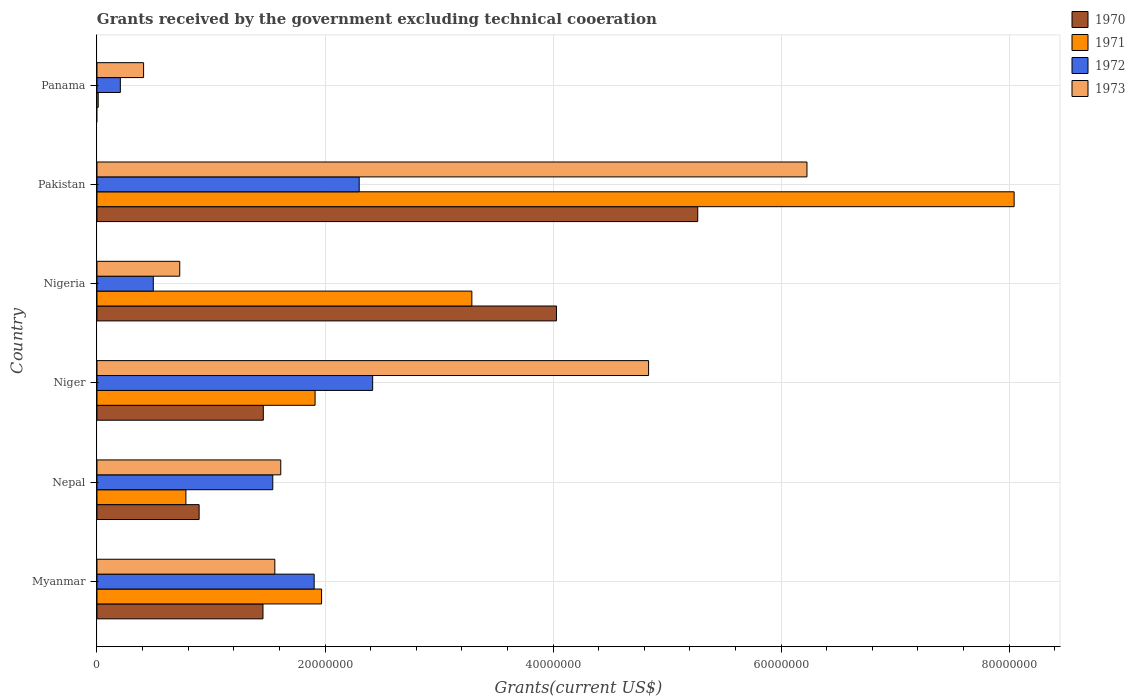How many different coloured bars are there?
Give a very brief answer. 4. Are the number of bars on each tick of the Y-axis equal?
Ensure brevity in your answer.  No. How many bars are there on the 2nd tick from the bottom?
Your answer should be very brief. 4. What is the label of the 2nd group of bars from the top?
Provide a short and direct response. Pakistan. In how many cases, is the number of bars for a given country not equal to the number of legend labels?
Your answer should be compact. 1. What is the total grants received by the government in 1970 in Pakistan?
Keep it short and to the point. 5.27e+07. Across all countries, what is the maximum total grants received by the government in 1973?
Offer a terse response. 6.23e+07. In which country was the total grants received by the government in 1973 maximum?
Keep it short and to the point. Pakistan. What is the total total grants received by the government in 1970 in the graph?
Provide a short and direct response. 1.31e+08. What is the difference between the total grants received by the government in 1971 in Niger and that in Nigeria?
Keep it short and to the point. -1.38e+07. What is the difference between the total grants received by the government in 1970 in Myanmar and the total grants received by the government in 1973 in Pakistan?
Ensure brevity in your answer.  -4.77e+07. What is the average total grants received by the government in 1971 per country?
Your answer should be very brief. 2.67e+07. What is the difference between the total grants received by the government in 1972 and total grants received by the government in 1971 in Nigeria?
Offer a terse response. -2.79e+07. In how many countries, is the total grants received by the government in 1971 greater than 64000000 US$?
Provide a succinct answer. 1. What is the ratio of the total grants received by the government in 1970 in Nepal to that in Niger?
Provide a short and direct response. 0.61. What is the difference between the highest and the second highest total grants received by the government in 1971?
Offer a very short reply. 4.76e+07. What is the difference between the highest and the lowest total grants received by the government in 1972?
Offer a terse response. 2.21e+07. In how many countries, is the total grants received by the government in 1972 greater than the average total grants received by the government in 1972 taken over all countries?
Your answer should be very brief. 4. How many bars are there?
Your answer should be very brief. 23. Are all the bars in the graph horizontal?
Offer a very short reply. Yes. What is the difference between two consecutive major ticks on the X-axis?
Provide a short and direct response. 2.00e+07. Does the graph contain any zero values?
Keep it short and to the point. Yes. Where does the legend appear in the graph?
Provide a short and direct response. Top right. How many legend labels are there?
Your answer should be compact. 4. How are the legend labels stacked?
Make the answer very short. Vertical. What is the title of the graph?
Your answer should be compact. Grants received by the government excluding technical cooeration. What is the label or title of the X-axis?
Ensure brevity in your answer.  Grants(current US$). What is the Grants(current US$) in 1970 in Myanmar?
Provide a short and direct response. 1.46e+07. What is the Grants(current US$) of 1971 in Myanmar?
Keep it short and to the point. 1.97e+07. What is the Grants(current US$) in 1972 in Myanmar?
Offer a very short reply. 1.90e+07. What is the Grants(current US$) in 1973 in Myanmar?
Your answer should be compact. 1.56e+07. What is the Grants(current US$) in 1970 in Nepal?
Provide a short and direct response. 8.96e+06. What is the Grants(current US$) in 1971 in Nepal?
Give a very brief answer. 7.80e+06. What is the Grants(current US$) in 1972 in Nepal?
Give a very brief answer. 1.54e+07. What is the Grants(current US$) of 1973 in Nepal?
Provide a short and direct response. 1.61e+07. What is the Grants(current US$) of 1970 in Niger?
Your response must be concise. 1.46e+07. What is the Grants(current US$) in 1971 in Niger?
Your answer should be very brief. 1.91e+07. What is the Grants(current US$) of 1972 in Niger?
Provide a succinct answer. 2.42e+07. What is the Grants(current US$) in 1973 in Niger?
Your response must be concise. 4.84e+07. What is the Grants(current US$) in 1970 in Nigeria?
Provide a succinct answer. 4.03e+07. What is the Grants(current US$) of 1971 in Nigeria?
Provide a succinct answer. 3.29e+07. What is the Grants(current US$) of 1972 in Nigeria?
Provide a short and direct response. 4.94e+06. What is the Grants(current US$) in 1973 in Nigeria?
Offer a terse response. 7.26e+06. What is the Grants(current US$) in 1970 in Pakistan?
Ensure brevity in your answer.  5.27e+07. What is the Grants(current US$) of 1971 in Pakistan?
Your answer should be compact. 8.04e+07. What is the Grants(current US$) in 1972 in Pakistan?
Keep it short and to the point. 2.30e+07. What is the Grants(current US$) in 1973 in Pakistan?
Provide a short and direct response. 6.23e+07. What is the Grants(current US$) in 1970 in Panama?
Make the answer very short. 0. What is the Grants(current US$) of 1971 in Panama?
Ensure brevity in your answer.  1.10e+05. What is the Grants(current US$) of 1972 in Panama?
Give a very brief answer. 2.05e+06. What is the Grants(current US$) of 1973 in Panama?
Give a very brief answer. 4.09e+06. Across all countries, what is the maximum Grants(current US$) in 1970?
Give a very brief answer. 5.27e+07. Across all countries, what is the maximum Grants(current US$) in 1971?
Give a very brief answer. 8.04e+07. Across all countries, what is the maximum Grants(current US$) in 1972?
Provide a succinct answer. 2.42e+07. Across all countries, what is the maximum Grants(current US$) of 1973?
Give a very brief answer. 6.23e+07. Across all countries, what is the minimum Grants(current US$) in 1970?
Provide a succinct answer. 0. Across all countries, what is the minimum Grants(current US$) in 1971?
Ensure brevity in your answer.  1.10e+05. Across all countries, what is the minimum Grants(current US$) in 1972?
Keep it short and to the point. 2.05e+06. Across all countries, what is the minimum Grants(current US$) of 1973?
Give a very brief answer. 4.09e+06. What is the total Grants(current US$) of 1970 in the graph?
Your answer should be compact. 1.31e+08. What is the total Grants(current US$) in 1971 in the graph?
Make the answer very short. 1.60e+08. What is the total Grants(current US$) of 1972 in the graph?
Your answer should be very brief. 8.86e+07. What is the total Grants(current US$) of 1973 in the graph?
Give a very brief answer. 1.54e+08. What is the difference between the Grants(current US$) in 1970 in Myanmar and that in Nepal?
Keep it short and to the point. 5.60e+06. What is the difference between the Grants(current US$) of 1971 in Myanmar and that in Nepal?
Make the answer very short. 1.19e+07. What is the difference between the Grants(current US$) of 1972 in Myanmar and that in Nepal?
Make the answer very short. 3.63e+06. What is the difference between the Grants(current US$) in 1973 in Myanmar and that in Nepal?
Offer a very short reply. -5.20e+05. What is the difference between the Grants(current US$) of 1971 in Myanmar and that in Niger?
Ensure brevity in your answer.  5.70e+05. What is the difference between the Grants(current US$) of 1972 in Myanmar and that in Niger?
Keep it short and to the point. -5.13e+06. What is the difference between the Grants(current US$) in 1973 in Myanmar and that in Niger?
Provide a succinct answer. -3.28e+07. What is the difference between the Grants(current US$) of 1970 in Myanmar and that in Nigeria?
Ensure brevity in your answer.  -2.57e+07. What is the difference between the Grants(current US$) in 1971 in Myanmar and that in Nigeria?
Ensure brevity in your answer.  -1.32e+07. What is the difference between the Grants(current US$) in 1972 in Myanmar and that in Nigeria?
Keep it short and to the point. 1.41e+07. What is the difference between the Grants(current US$) of 1973 in Myanmar and that in Nigeria?
Ensure brevity in your answer.  8.34e+06. What is the difference between the Grants(current US$) in 1970 in Myanmar and that in Pakistan?
Keep it short and to the point. -3.81e+07. What is the difference between the Grants(current US$) of 1971 in Myanmar and that in Pakistan?
Offer a terse response. -6.07e+07. What is the difference between the Grants(current US$) in 1972 in Myanmar and that in Pakistan?
Make the answer very short. -3.95e+06. What is the difference between the Grants(current US$) in 1973 in Myanmar and that in Pakistan?
Provide a short and direct response. -4.67e+07. What is the difference between the Grants(current US$) in 1971 in Myanmar and that in Panama?
Your response must be concise. 1.96e+07. What is the difference between the Grants(current US$) of 1972 in Myanmar and that in Panama?
Provide a succinct answer. 1.70e+07. What is the difference between the Grants(current US$) in 1973 in Myanmar and that in Panama?
Offer a terse response. 1.15e+07. What is the difference between the Grants(current US$) in 1970 in Nepal and that in Niger?
Make the answer very short. -5.63e+06. What is the difference between the Grants(current US$) in 1971 in Nepal and that in Niger?
Your response must be concise. -1.13e+07. What is the difference between the Grants(current US$) in 1972 in Nepal and that in Niger?
Your response must be concise. -8.76e+06. What is the difference between the Grants(current US$) in 1973 in Nepal and that in Niger?
Your response must be concise. -3.23e+07. What is the difference between the Grants(current US$) of 1970 in Nepal and that in Nigeria?
Your answer should be compact. -3.13e+07. What is the difference between the Grants(current US$) in 1971 in Nepal and that in Nigeria?
Give a very brief answer. -2.51e+07. What is the difference between the Grants(current US$) of 1972 in Nepal and that in Nigeria?
Make the answer very short. 1.05e+07. What is the difference between the Grants(current US$) of 1973 in Nepal and that in Nigeria?
Offer a very short reply. 8.86e+06. What is the difference between the Grants(current US$) of 1970 in Nepal and that in Pakistan?
Give a very brief answer. -4.37e+07. What is the difference between the Grants(current US$) of 1971 in Nepal and that in Pakistan?
Ensure brevity in your answer.  -7.26e+07. What is the difference between the Grants(current US$) of 1972 in Nepal and that in Pakistan?
Ensure brevity in your answer.  -7.58e+06. What is the difference between the Grants(current US$) in 1973 in Nepal and that in Pakistan?
Your response must be concise. -4.62e+07. What is the difference between the Grants(current US$) in 1971 in Nepal and that in Panama?
Your response must be concise. 7.69e+06. What is the difference between the Grants(current US$) of 1972 in Nepal and that in Panama?
Make the answer very short. 1.34e+07. What is the difference between the Grants(current US$) in 1973 in Nepal and that in Panama?
Offer a terse response. 1.20e+07. What is the difference between the Grants(current US$) in 1970 in Niger and that in Nigeria?
Make the answer very short. -2.57e+07. What is the difference between the Grants(current US$) of 1971 in Niger and that in Nigeria?
Give a very brief answer. -1.38e+07. What is the difference between the Grants(current US$) in 1972 in Niger and that in Nigeria?
Provide a short and direct response. 1.92e+07. What is the difference between the Grants(current US$) of 1973 in Niger and that in Nigeria?
Provide a short and direct response. 4.11e+07. What is the difference between the Grants(current US$) in 1970 in Niger and that in Pakistan?
Your answer should be compact. -3.81e+07. What is the difference between the Grants(current US$) in 1971 in Niger and that in Pakistan?
Your answer should be very brief. -6.13e+07. What is the difference between the Grants(current US$) in 1972 in Niger and that in Pakistan?
Keep it short and to the point. 1.18e+06. What is the difference between the Grants(current US$) of 1973 in Niger and that in Pakistan?
Ensure brevity in your answer.  -1.39e+07. What is the difference between the Grants(current US$) in 1971 in Niger and that in Panama?
Offer a very short reply. 1.90e+07. What is the difference between the Grants(current US$) of 1972 in Niger and that in Panama?
Provide a short and direct response. 2.21e+07. What is the difference between the Grants(current US$) of 1973 in Niger and that in Panama?
Your answer should be very brief. 4.43e+07. What is the difference between the Grants(current US$) in 1970 in Nigeria and that in Pakistan?
Offer a very short reply. -1.24e+07. What is the difference between the Grants(current US$) of 1971 in Nigeria and that in Pakistan?
Your answer should be very brief. -4.76e+07. What is the difference between the Grants(current US$) of 1972 in Nigeria and that in Pakistan?
Your answer should be very brief. -1.81e+07. What is the difference between the Grants(current US$) in 1973 in Nigeria and that in Pakistan?
Provide a short and direct response. -5.50e+07. What is the difference between the Grants(current US$) of 1971 in Nigeria and that in Panama?
Offer a terse response. 3.28e+07. What is the difference between the Grants(current US$) in 1972 in Nigeria and that in Panama?
Make the answer very short. 2.89e+06. What is the difference between the Grants(current US$) in 1973 in Nigeria and that in Panama?
Provide a succinct answer. 3.17e+06. What is the difference between the Grants(current US$) of 1971 in Pakistan and that in Panama?
Provide a succinct answer. 8.03e+07. What is the difference between the Grants(current US$) of 1972 in Pakistan and that in Panama?
Your answer should be compact. 2.10e+07. What is the difference between the Grants(current US$) in 1973 in Pakistan and that in Panama?
Give a very brief answer. 5.82e+07. What is the difference between the Grants(current US$) in 1970 in Myanmar and the Grants(current US$) in 1971 in Nepal?
Offer a terse response. 6.76e+06. What is the difference between the Grants(current US$) of 1970 in Myanmar and the Grants(current US$) of 1972 in Nepal?
Provide a succinct answer. -8.60e+05. What is the difference between the Grants(current US$) in 1970 in Myanmar and the Grants(current US$) in 1973 in Nepal?
Your response must be concise. -1.56e+06. What is the difference between the Grants(current US$) in 1971 in Myanmar and the Grants(current US$) in 1972 in Nepal?
Offer a terse response. 4.28e+06. What is the difference between the Grants(current US$) of 1971 in Myanmar and the Grants(current US$) of 1973 in Nepal?
Offer a terse response. 3.58e+06. What is the difference between the Grants(current US$) in 1972 in Myanmar and the Grants(current US$) in 1973 in Nepal?
Make the answer very short. 2.93e+06. What is the difference between the Grants(current US$) of 1970 in Myanmar and the Grants(current US$) of 1971 in Niger?
Make the answer very short. -4.57e+06. What is the difference between the Grants(current US$) in 1970 in Myanmar and the Grants(current US$) in 1972 in Niger?
Ensure brevity in your answer.  -9.62e+06. What is the difference between the Grants(current US$) in 1970 in Myanmar and the Grants(current US$) in 1973 in Niger?
Your answer should be compact. -3.38e+07. What is the difference between the Grants(current US$) in 1971 in Myanmar and the Grants(current US$) in 1972 in Niger?
Ensure brevity in your answer.  -4.48e+06. What is the difference between the Grants(current US$) in 1971 in Myanmar and the Grants(current US$) in 1973 in Niger?
Keep it short and to the point. -2.87e+07. What is the difference between the Grants(current US$) in 1972 in Myanmar and the Grants(current US$) in 1973 in Niger?
Your answer should be compact. -2.93e+07. What is the difference between the Grants(current US$) in 1970 in Myanmar and the Grants(current US$) in 1971 in Nigeria?
Give a very brief answer. -1.83e+07. What is the difference between the Grants(current US$) of 1970 in Myanmar and the Grants(current US$) of 1972 in Nigeria?
Ensure brevity in your answer.  9.62e+06. What is the difference between the Grants(current US$) of 1970 in Myanmar and the Grants(current US$) of 1973 in Nigeria?
Provide a succinct answer. 7.30e+06. What is the difference between the Grants(current US$) of 1971 in Myanmar and the Grants(current US$) of 1972 in Nigeria?
Provide a short and direct response. 1.48e+07. What is the difference between the Grants(current US$) of 1971 in Myanmar and the Grants(current US$) of 1973 in Nigeria?
Make the answer very short. 1.24e+07. What is the difference between the Grants(current US$) of 1972 in Myanmar and the Grants(current US$) of 1973 in Nigeria?
Offer a terse response. 1.18e+07. What is the difference between the Grants(current US$) of 1970 in Myanmar and the Grants(current US$) of 1971 in Pakistan?
Make the answer very short. -6.59e+07. What is the difference between the Grants(current US$) of 1970 in Myanmar and the Grants(current US$) of 1972 in Pakistan?
Give a very brief answer. -8.44e+06. What is the difference between the Grants(current US$) of 1970 in Myanmar and the Grants(current US$) of 1973 in Pakistan?
Offer a very short reply. -4.77e+07. What is the difference between the Grants(current US$) of 1971 in Myanmar and the Grants(current US$) of 1972 in Pakistan?
Offer a terse response. -3.30e+06. What is the difference between the Grants(current US$) in 1971 in Myanmar and the Grants(current US$) in 1973 in Pakistan?
Your response must be concise. -4.26e+07. What is the difference between the Grants(current US$) of 1972 in Myanmar and the Grants(current US$) of 1973 in Pakistan?
Ensure brevity in your answer.  -4.32e+07. What is the difference between the Grants(current US$) in 1970 in Myanmar and the Grants(current US$) in 1971 in Panama?
Make the answer very short. 1.44e+07. What is the difference between the Grants(current US$) of 1970 in Myanmar and the Grants(current US$) of 1972 in Panama?
Make the answer very short. 1.25e+07. What is the difference between the Grants(current US$) of 1970 in Myanmar and the Grants(current US$) of 1973 in Panama?
Provide a short and direct response. 1.05e+07. What is the difference between the Grants(current US$) in 1971 in Myanmar and the Grants(current US$) in 1972 in Panama?
Offer a terse response. 1.76e+07. What is the difference between the Grants(current US$) of 1971 in Myanmar and the Grants(current US$) of 1973 in Panama?
Your answer should be very brief. 1.56e+07. What is the difference between the Grants(current US$) in 1972 in Myanmar and the Grants(current US$) in 1973 in Panama?
Make the answer very short. 1.50e+07. What is the difference between the Grants(current US$) in 1970 in Nepal and the Grants(current US$) in 1971 in Niger?
Keep it short and to the point. -1.02e+07. What is the difference between the Grants(current US$) of 1970 in Nepal and the Grants(current US$) of 1972 in Niger?
Your answer should be very brief. -1.52e+07. What is the difference between the Grants(current US$) of 1970 in Nepal and the Grants(current US$) of 1973 in Niger?
Offer a very short reply. -3.94e+07. What is the difference between the Grants(current US$) in 1971 in Nepal and the Grants(current US$) in 1972 in Niger?
Make the answer very short. -1.64e+07. What is the difference between the Grants(current US$) in 1971 in Nepal and the Grants(current US$) in 1973 in Niger?
Ensure brevity in your answer.  -4.06e+07. What is the difference between the Grants(current US$) in 1972 in Nepal and the Grants(current US$) in 1973 in Niger?
Offer a very short reply. -3.30e+07. What is the difference between the Grants(current US$) in 1970 in Nepal and the Grants(current US$) in 1971 in Nigeria?
Give a very brief answer. -2.39e+07. What is the difference between the Grants(current US$) of 1970 in Nepal and the Grants(current US$) of 1972 in Nigeria?
Provide a short and direct response. 4.02e+06. What is the difference between the Grants(current US$) of 1970 in Nepal and the Grants(current US$) of 1973 in Nigeria?
Your answer should be very brief. 1.70e+06. What is the difference between the Grants(current US$) of 1971 in Nepal and the Grants(current US$) of 1972 in Nigeria?
Provide a succinct answer. 2.86e+06. What is the difference between the Grants(current US$) in 1971 in Nepal and the Grants(current US$) in 1973 in Nigeria?
Offer a very short reply. 5.40e+05. What is the difference between the Grants(current US$) of 1972 in Nepal and the Grants(current US$) of 1973 in Nigeria?
Your answer should be very brief. 8.16e+06. What is the difference between the Grants(current US$) in 1970 in Nepal and the Grants(current US$) in 1971 in Pakistan?
Your answer should be compact. -7.15e+07. What is the difference between the Grants(current US$) of 1970 in Nepal and the Grants(current US$) of 1972 in Pakistan?
Ensure brevity in your answer.  -1.40e+07. What is the difference between the Grants(current US$) of 1970 in Nepal and the Grants(current US$) of 1973 in Pakistan?
Your answer should be compact. -5.33e+07. What is the difference between the Grants(current US$) of 1971 in Nepal and the Grants(current US$) of 1972 in Pakistan?
Make the answer very short. -1.52e+07. What is the difference between the Grants(current US$) of 1971 in Nepal and the Grants(current US$) of 1973 in Pakistan?
Provide a succinct answer. -5.45e+07. What is the difference between the Grants(current US$) of 1972 in Nepal and the Grants(current US$) of 1973 in Pakistan?
Your answer should be compact. -4.68e+07. What is the difference between the Grants(current US$) in 1970 in Nepal and the Grants(current US$) in 1971 in Panama?
Ensure brevity in your answer.  8.85e+06. What is the difference between the Grants(current US$) of 1970 in Nepal and the Grants(current US$) of 1972 in Panama?
Keep it short and to the point. 6.91e+06. What is the difference between the Grants(current US$) in 1970 in Nepal and the Grants(current US$) in 1973 in Panama?
Your answer should be very brief. 4.87e+06. What is the difference between the Grants(current US$) of 1971 in Nepal and the Grants(current US$) of 1972 in Panama?
Your answer should be very brief. 5.75e+06. What is the difference between the Grants(current US$) in 1971 in Nepal and the Grants(current US$) in 1973 in Panama?
Keep it short and to the point. 3.71e+06. What is the difference between the Grants(current US$) in 1972 in Nepal and the Grants(current US$) in 1973 in Panama?
Your answer should be very brief. 1.13e+07. What is the difference between the Grants(current US$) in 1970 in Niger and the Grants(current US$) in 1971 in Nigeria?
Offer a terse response. -1.83e+07. What is the difference between the Grants(current US$) of 1970 in Niger and the Grants(current US$) of 1972 in Nigeria?
Give a very brief answer. 9.65e+06. What is the difference between the Grants(current US$) in 1970 in Niger and the Grants(current US$) in 1973 in Nigeria?
Provide a succinct answer. 7.33e+06. What is the difference between the Grants(current US$) in 1971 in Niger and the Grants(current US$) in 1972 in Nigeria?
Give a very brief answer. 1.42e+07. What is the difference between the Grants(current US$) of 1971 in Niger and the Grants(current US$) of 1973 in Nigeria?
Make the answer very short. 1.19e+07. What is the difference between the Grants(current US$) in 1972 in Niger and the Grants(current US$) in 1973 in Nigeria?
Keep it short and to the point. 1.69e+07. What is the difference between the Grants(current US$) of 1970 in Niger and the Grants(current US$) of 1971 in Pakistan?
Ensure brevity in your answer.  -6.58e+07. What is the difference between the Grants(current US$) in 1970 in Niger and the Grants(current US$) in 1972 in Pakistan?
Your answer should be very brief. -8.41e+06. What is the difference between the Grants(current US$) in 1970 in Niger and the Grants(current US$) in 1973 in Pakistan?
Ensure brevity in your answer.  -4.77e+07. What is the difference between the Grants(current US$) of 1971 in Niger and the Grants(current US$) of 1972 in Pakistan?
Offer a terse response. -3.87e+06. What is the difference between the Grants(current US$) in 1971 in Niger and the Grants(current US$) in 1973 in Pakistan?
Give a very brief answer. -4.31e+07. What is the difference between the Grants(current US$) in 1972 in Niger and the Grants(current US$) in 1973 in Pakistan?
Provide a short and direct response. -3.81e+07. What is the difference between the Grants(current US$) of 1970 in Niger and the Grants(current US$) of 1971 in Panama?
Offer a terse response. 1.45e+07. What is the difference between the Grants(current US$) in 1970 in Niger and the Grants(current US$) in 1972 in Panama?
Make the answer very short. 1.25e+07. What is the difference between the Grants(current US$) of 1970 in Niger and the Grants(current US$) of 1973 in Panama?
Make the answer very short. 1.05e+07. What is the difference between the Grants(current US$) of 1971 in Niger and the Grants(current US$) of 1972 in Panama?
Give a very brief answer. 1.71e+07. What is the difference between the Grants(current US$) of 1971 in Niger and the Grants(current US$) of 1973 in Panama?
Offer a terse response. 1.50e+07. What is the difference between the Grants(current US$) in 1972 in Niger and the Grants(current US$) in 1973 in Panama?
Provide a short and direct response. 2.01e+07. What is the difference between the Grants(current US$) of 1970 in Nigeria and the Grants(current US$) of 1971 in Pakistan?
Ensure brevity in your answer.  -4.01e+07. What is the difference between the Grants(current US$) in 1970 in Nigeria and the Grants(current US$) in 1972 in Pakistan?
Offer a terse response. 1.73e+07. What is the difference between the Grants(current US$) in 1970 in Nigeria and the Grants(current US$) in 1973 in Pakistan?
Give a very brief answer. -2.20e+07. What is the difference between the Grants(current US$) in 1971 in Nigeria and the Grants(current US$) in 1972 in Pakistan?
Keep it short and to the point. 9.88e+06. What is the difference between the Grants(current US$) of 1971 in Nigeria and the Grants(current US$) of 1973 in Pakistan?
Give a very brief answer. -2.94e+07. What is the difference between the Grants(current US$) of 1972 in Nigeria and the Grants(current US$) of 1973 in Pakistan?
Your response must be concise. -5.73e+07. What is the difference between the Grants(current US$) in 1970 in Nigeria and the Grants(current US$) in 1971 in Panama?
Your answer should be very brief. 4.02e+07. What is the difference between the Grants(current US$) of 1970 in Nigeria and the Grants(current US$) of 1972 in Panama?
Ensure brevity in your answer.  3.82e+07. What is the difference between the Grants(current US$) of 1970 in Nigeria and the Grants(current US$) of 1973 in Panama?
Make the answer very short. 3.62e+07. What is the difference between the Grants(current US$) of 1971 in Nigeria and the Grants(current US$) of 1972 in Panama?
Provide a short and direct response. 3.08e+07. What is the difference between the Grants(current US$) in 1971 in Nigeria and the Grants(current US$) in 1973 in Panama?
Your answer should be very brief. 2.88e+07. What is the difference between the Grants(current US$) in 1972 in Nigeria and the Grants(current US$) in 1973 in Panama?
Ensure brevity in your answer.  8.50e+05. What is the difference between the Grants(current US$) of 1970 in Pakistan and the Grants(current US$) of 1971 in Panama?
Make the answer very short. 5.26e+07. What is the difference between the Grants(current US$) of 1970 in Pakistan and the Grants(current US$) of 1972 in Panama?
Offer a terse response. 5.06e+07. What is the difference between the Grants(current US$) of 1970 in Pakistan and the Grants(current US$) of 1973 in Panama?
Provide a succinct answer. 4.86e+07. What is the difference between the Grants(current US$) of 1971 in Pakistan and the Grants(current US$) of 1972 in Panama?
Offer a terse response. 7.84e+07. What is the difference between the Grants(current US$) in 1971 in Pakistan and the Grants(current US$) in 1973 in Panama?
Keep it short and to the point. 7.64e+07. What is the difference between the Grants(current US$) in 1972 in Pakistan and the Grants(current US$) in 1973 in Panama?
Keep it short and to the point. 1.89e+07. What is the average Grants(current US$) of 1970 per country?
Your answer should be compact. 2.18e+07. What is the average Grants(current US$) in 1971 per country?
Your response must be concise. 2.67e+07. What is the average Grants(current US$) in 1972 per country?
Provide a succinct answer. 1.48e+07. What is the average Grants(current US$) of 1973 per country?
Your answer should be compact. 2.56e+07. What is the difference between the Grants(current US$) in 1970 and Grants(current US$) in 1971 in Myanmar?
Offer a terse response. -5.14e+06. What is the difference between the Grants(current US$) in 1970 and Grants(current US$) in 1972 in Myanmar?
Give a very brief answer. -4.49e+06. What is the difference between the Grants(current US$) in 1970 and Grants(current US$) in 1973 in Myanmar?
Make the answer very short. -1.04e+06. What is the difference between the Grants(current US$) in 1971 and Grants(current US$) in 1972 in Myanmar?
Provide a succinct answer. 6.50e+05. What is the difference between the Grants(current US$) of 1971 and Grants(current US$) of 1973 in Myanmar?
Your answer should be very brief. 4.10e+06. What is the difference between the Grants(current US$) of 1972 and Grants(current US$) of 1973 in Myanmar?
Provide a succinct answer. 3.45e+06. What is the difference between the Grants(current US$) in 1970 and Grants(current US$) in 1971 in Nepal?
Keep it short and to the point. 1.16e+06. What is the difference between the Grants(current US$) in 1970 and Grants(current US$) in 1972 in Nepal?
Offer a terse response. -6.46e+06. What is the difference between the Grants(current US$) of 1970 and Grants(current US$) of 1973 in Nepal?
Provide a short and direct response. -7.16e+06. What is the difference between the Grants(current US$) of 1971 and Grants(current US$) of 1972 in Nepal?
Give a very brief answer. -7.62e+06. What is the difference between the Grants(current US$) in 1971 and Grants(current US$) in 1973 in Nepal?
Offer a terse response. -8.32e+06. What is the difference between the Grants(current US$) of 1972 and Grants(current US$) of 1973 in Nepal?
Your response must be concise. -7.00e+05. What is the difference between the Grants(current US$) in 1970 and Grants(current US$) in 1971 in Niger?
Give a very brief answer. -4.54e+06. What is the difference between the Grants(current US$) of 1970 and Grants(current US$) of 1972 in Niger?
Provide a short and direct response. -9.59e+06. What is the difference between the Grants(current US$) of 1970 and Grants(current US$) of 1973 in Niger?
Your response must be concise. -3.38e+07. What is the difference between the Grants(current US$) in 1971 and Grants(current US$) in 1972 in Niger?
Offer a terse response. -5.05e+06. What is the difference between the Grants(current US$) in 1971 and Grants(current US$) in 1973 in Niger?
Offer a very short reply. -2.92e+07. What is the difference between the Grants(current US$) in 1972 and Grants(current US$) in 1973 in Niger?
Make the answer very short. -2.42e+07. What is the difference between the Grants(current US$) of 1970 and Grants(current US$) of 1971 in Nigeria?
Offer a terse response. 7.42e+06. What is the difference between the Grants(current US$) of 1970 and Grants(current US$) of 1972 in Nigeria?
Provide a short and direct response. 3.54e+07. What is the difference between the Grants(current US$) of 1970 and Grants(current US$) of 1973 in Nigeria?
Your answer should be compact. 3.30e+07. What is the difference between the Grants(current US$) in 1971 and Grants(current US$) in 1972 in Nigeria?
Offer a very short reply. 2.79e+07. What is the difference between the Grants(current US$) in 1971 and Grants(current US$) in 1973 in Nigeria?
Offer a terse response. 2.56e+07. What is the difference between the Grants(current US$) of 1972 and Grants(current US$) of 1973 in Nigeria?
Your answer should be very brief. -2.32e+06. What is the difference between the Grants(current US$) of 1970 and Grants(current US$) of 1971 in Pakistan?
Provide a short and direct response. -2.78e+07. What is the difference between the Grants(current US$) of 1970 and Grants(current US$) of 1972 in Pakistan?
Your answer should be very brief. 2.97e+07. What is the difference between the Grants(current US$) in 1970 and Grants(current US$) in 1973 in Pakistan?
Provide a succinct answer. -9.58e+06. What is the difference between the Grants(current US$) in 1971 and Grants(current US$) in 1972 in Pakistan?
Your answer should be compact. 5.74e+07. What is the difference between the Grants(current US$) in 1971 and Grants(current US$) in 1973 in Pakistan?
Your response must be concise. 1.82e+07. What is the difference between the Grants(current US$) of 1972 and Grants(current US$) of 1973 in Pakistan?
Your response must be concise. -3.93e+07. What is the difference between the Grants(current US$) of 1971 and Grants(current US$) of 1972 in Panama?
Your answer should be compact. -1.94e+06. What is the difference between the Grants(current US$) in 1971 and Grants(current US$) in 1973 in Panama?
Provide a short and direct response. -3.98e+06. What is the difference between the Grants(current US$) of 1972 and Grants(current US$) of 1973 in Panama?
Provide a succinct answer. -2.04e+06. What is the ratio of the Grants(current US$) of 1970 in Myanmar to that in Nepal?
Keep it short and to the point. 1.62. What is the ratio of the Grants(current US$) in 1971 in Myanmar to that in Nepal?
Keep it short and to the point. 2.53. What is the ratio of the Grants(current US$) in 1972 in Myanmar to that in Nepal?
Give a very brief answer. 1.24. What is the ratio of the Grants(current US$) in 1973 in Myanmar to that in Nepal?
Your answer should be compact. 0.97. What is the ratio of the Grants(current US$) of 1971 in Myanmar to that in Niger?
Make the answer very short. 1.03. What is the ratio of the Grants(current US$) of 1972 in Myanmar to that in Niger?
Your answer should be very brief. 0.79. What is the ratio of the Grants(current US$) in 1973 in Myanmar to that in Niger?
Ensure brevity in your answer.  0.32. What is the ratio of the Grants(current US$) of 1970 in Myanmar to that in Nigeria?
Offer a terse response. 0.36. What is the ratio of the Grants(current US$) in 1971 in Myanmar to that in Nigeria?
Keep it short and to the point. 0.6. What is the ratio of the Grants(current US$) in 1972 in Myanmar to that in Nigeria?
Give a very brief answer. 3.86. What is the ratio of the Grants(current US$) of 1973 in Myanmar to that in Nigeria?
Offer a terse response. 2.15. What is the ratio of the Grants(current US$) in 1970 in Myanmar to that in Pakistan?
Offer a terse response. 0.28. What is the ratio of the Grants(current US$) in 1971 in Myanmar to that in Pakistan?
Provide a succinct answer. 0.24. What is the ratio of the Grants(current US$) in 1972 in Myanmar to that in Pakistan?
Your answer should be compact. 0.83. What is the ratio of the Grants(current US$) in 1973 in Myanmar to that in Pakistan?
Ensure brevity in your answer.  0.25. What is the ratio of the Grants(current US$) of 1971 in Myanmar to that in Panama?
Provide a succinct answer. 179.09. What is the ratio of the Grants(current US$) of 1972 in Myanmar to that in Panama?
Offer a terse response. 9.29. What is the ratio of the Grants(current US$) in 1973 in Myanmar to that in Panama?
Keep it short and to the point. 3.81. What is the ratio of the Grants(current US$) in 1970 in Nepal to that in Niger?
Make the answer very short. 0.61. What is the ratio of the Grants(current US$) of 1971 in Nepal to that in Niger?
Offer a very short reply. 0.41. What is the ratio of the Grants(current US$) in 1972 in Nepal to that in Niger?
Ensure brevity in your answer.  0.64. What is the ratio of the Grants(current US$) in 1973 in Nepal to that in Niger?
Make the answer very short. 0.33. What is the ratio of the Grants(current US$) of 1970 in Nepal to that in Nigeria?
Your response must be concise. 0.22. What is the ratio of the Grants(current US$) in 1971 in Nepal to that in Nigeria?
Provide a succinct answer. 0.24. What is the ratio of the Grants(current US$) of 1972 in Nepal to that in Nigeria?
Keep it short and to the point. 3.12. What is the ratio of the Grants(current US$) in 1973 in Nepal to that in Nigeria?
Keep it short and to the point. 2.22. What is the ratio of the Grants(current US$) in 1970 in Nepal to that in Pakistan?
Provide a short and direct response. 0.17. What is the ratio of the Grants(current US$) in 1971 in Nepal to that in Pakistan?
Provide a short and direct response. 0.1. What is the ratio of the Grants(current US$) in 1972 in Nepal to that in Pakistan?
Provide a succinct answer. 0.67. What is the ratio of the Grants(current US$) in 1973 in Nepal to that in Pakistan?
Make the answer very short. 0.26. What is the ratio of the Grants(current US$) of 1971 in Nepal to that in Panama?
Provide a short and direct response. 70.91. What is the ratio of the Grants(current US$) in 1972 in Nepal to that in Panama?
Your answer should be compact. 7.52. What is the ratio of the Grants(current US$) of 1973 in Nepal to that in Panama?
Provide a short and direct response. 3.94. What is the ratio of the Grants(current US$) in 1970 in Niger to that in Nigeria?
Keep it short and to the point. 0.36. What is the ratio of the Grants(current US$) of 1971 in Niger to that in Nigeria?
Provide a short and direct response. 0.58. What is the ratio of the Grants(current US$) in 1972 in Niger to that in Nigeria?
Ensure brevity in your answer.  4.89. What is the ratio of the Grants(current US$) of 1973 in Niger to that in Nigeria?
Provide a succinct answer. 6.66. What is the ratio of the Grants(current US$) of 1970 in Niger to that in Pakistan?
Provide a short and direct response. 0.28. What is the ratio of the Grants(current US$) in 1971 in Niger to that in Pakistan?
Your answer should be very brief. 0.24. What is the ratio of the Grants(current US$) in 1972 in Niger to that in Pakistan?
Provide a succinct answer. 1.05. What is the ratio of the Grants(current US$) in 1973 in Niger to that in Pakistan?
Offer a very short reply. 0.78. What is the ratio of the Grants(current US$) in 1971 in Niger to that in Panama?
Ensure brevity in your answer.  173.91. What is the ratio of the Grants(current US$) of 1972 in Niger to that in Panama?
Your response must be concise. 11.8. What is the ratio of the Grants(current US$) in 1973 in Niger to that in Panama?
Make the answer very short. 11.83. What is the ratio of the Grants(current US$) in 1970 in Nigeria to that in Pakistan?
Provide a short and direct response. 0.76. What is the ratio of the Grants(current US$) of 1971 in Nigeria to that in Pakistan?
Your answer should be very brief. 0.41. What is the ratio of the Grants(current US$) in 1972 in Nigeria to that in Pakistan?
Your response must be concise. 0.21. What is the ratio of the Grants(current US$) of 1973 in Nigeria to that in Pakistan?
Keep it short and to the point. 0.12. What is the ratio of the Grants(current US$) in 1971 in Nigeria to that in Panama?
Provide a succinct answer. 298.91. What is the ratio of the Grants(current US$) of 1972 in Nigeria to that in Panama?
Provide a short and direct response. 2.41. What is the ratio of the Grants(current US$) of 1973 in Nigeria to that in Panama?
Provide a short and direct response. 1.78. What is the ratio of the Grants(current US$) of 1971 in Pakistan to that in Panama?
Offer a terse response. 731.27. What is the ratio of the Grants(current US$) of 1972 in Pakistan to that in Panama?
Ensure brevity in your answer.  11.22. What is the ratio of the Grants(current US$) in 1973 in Pakistan to that in Panama?
Make the answer very short. 15.22. What is the difference between the highest and the second highest Grants(current US$) of 1970?
Your answer should be compact. 1.24e+07. What is the difference between the highest and the second highest Grants(current US$) in 1971?
Keep it short and to the point. 4.76e+07. What is the difference between the highest and the second highest Grants(current US$) in 1972?
Your answer should be compact. 1.18e+06. What is the difference between the highest and the second highest Grants(current US$) in 1973?
Provide a short and direct response. 1.39e+07. What is the difference between the highest and the lowest Grants(current US$) of 1970?
Your answer should be very brief. 5.27e+07. What is the difference between the highest and the lowest Grants(current US$) in 1971?
Provide a succinct answer. 8.03e+07. What is the difference between the highest and the lowest Grants(current US$) of 1972?
Your response must be concise. 2.21e+07. What is the difference between the highest and the lowest Grants(current US$) of 1973?
Give a very brief answer. 5.82e+07. 